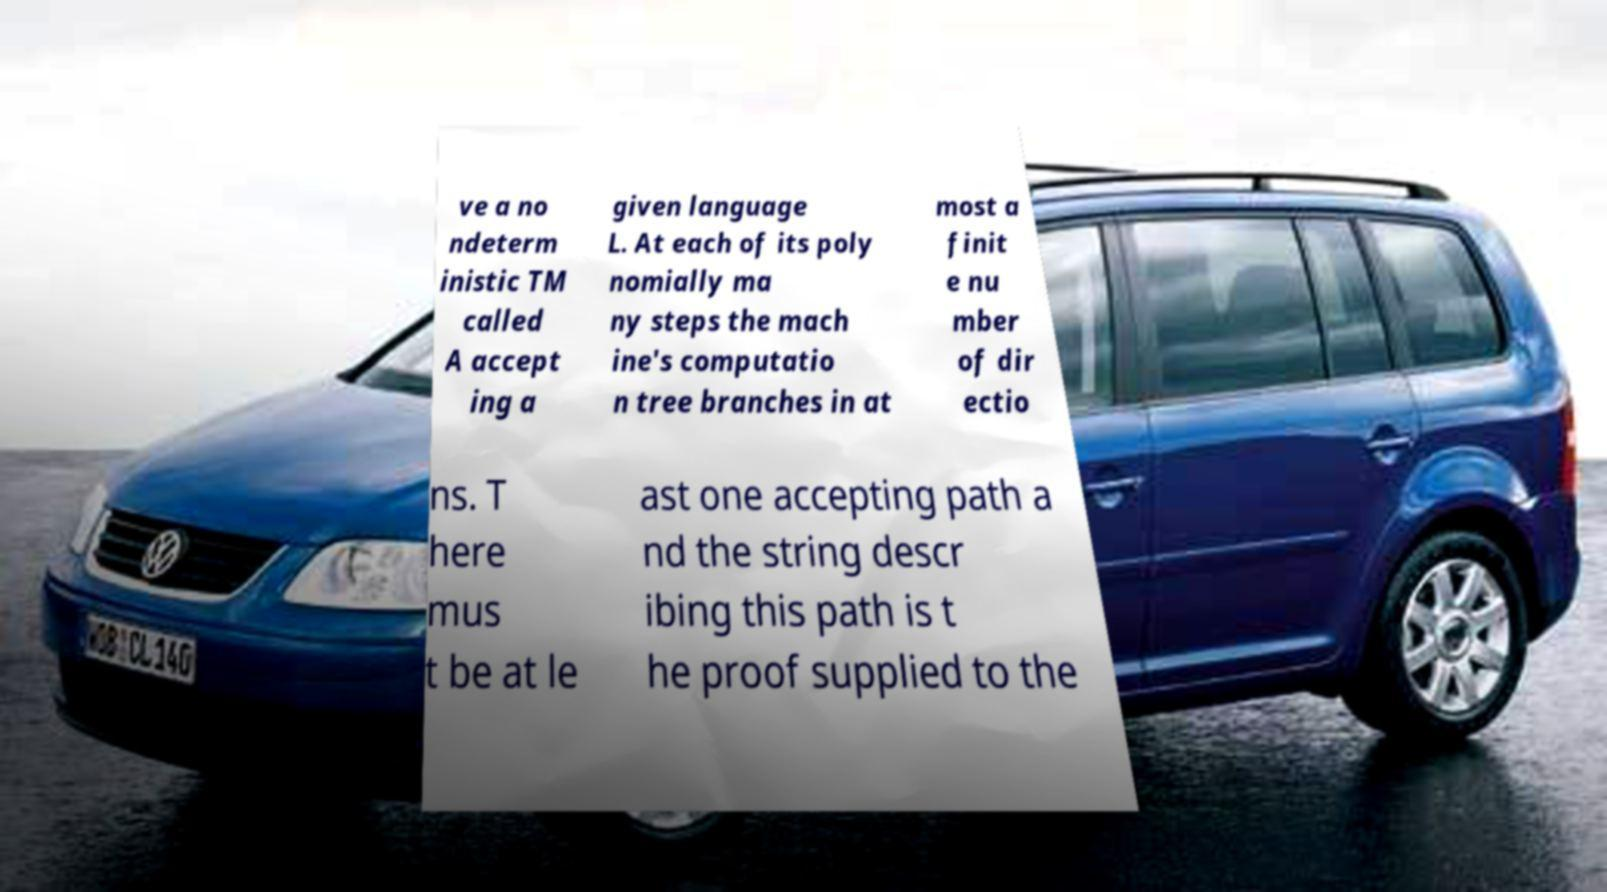I need the written content from this picture converted into text. Can you do that? ve a no ndeterm inistic TM called A accept ing a given language L. At each of its poly nomially ma ny steps the mach ine's computatio n tree branches in at most a finit e nu mber of dir ectio ns. T here mus t be at le ast one accepting path a nd the string descr ibing this path is t he proof supplied to the 